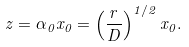<formula> <loc_0><loc_0><loc_500><loc_500>z = \alpha _ { 0 } x _ { 0 } = \left ( \frac { r } { D } \right ) ^ { 1 / 2 } x _ { 0 } .</formula> 